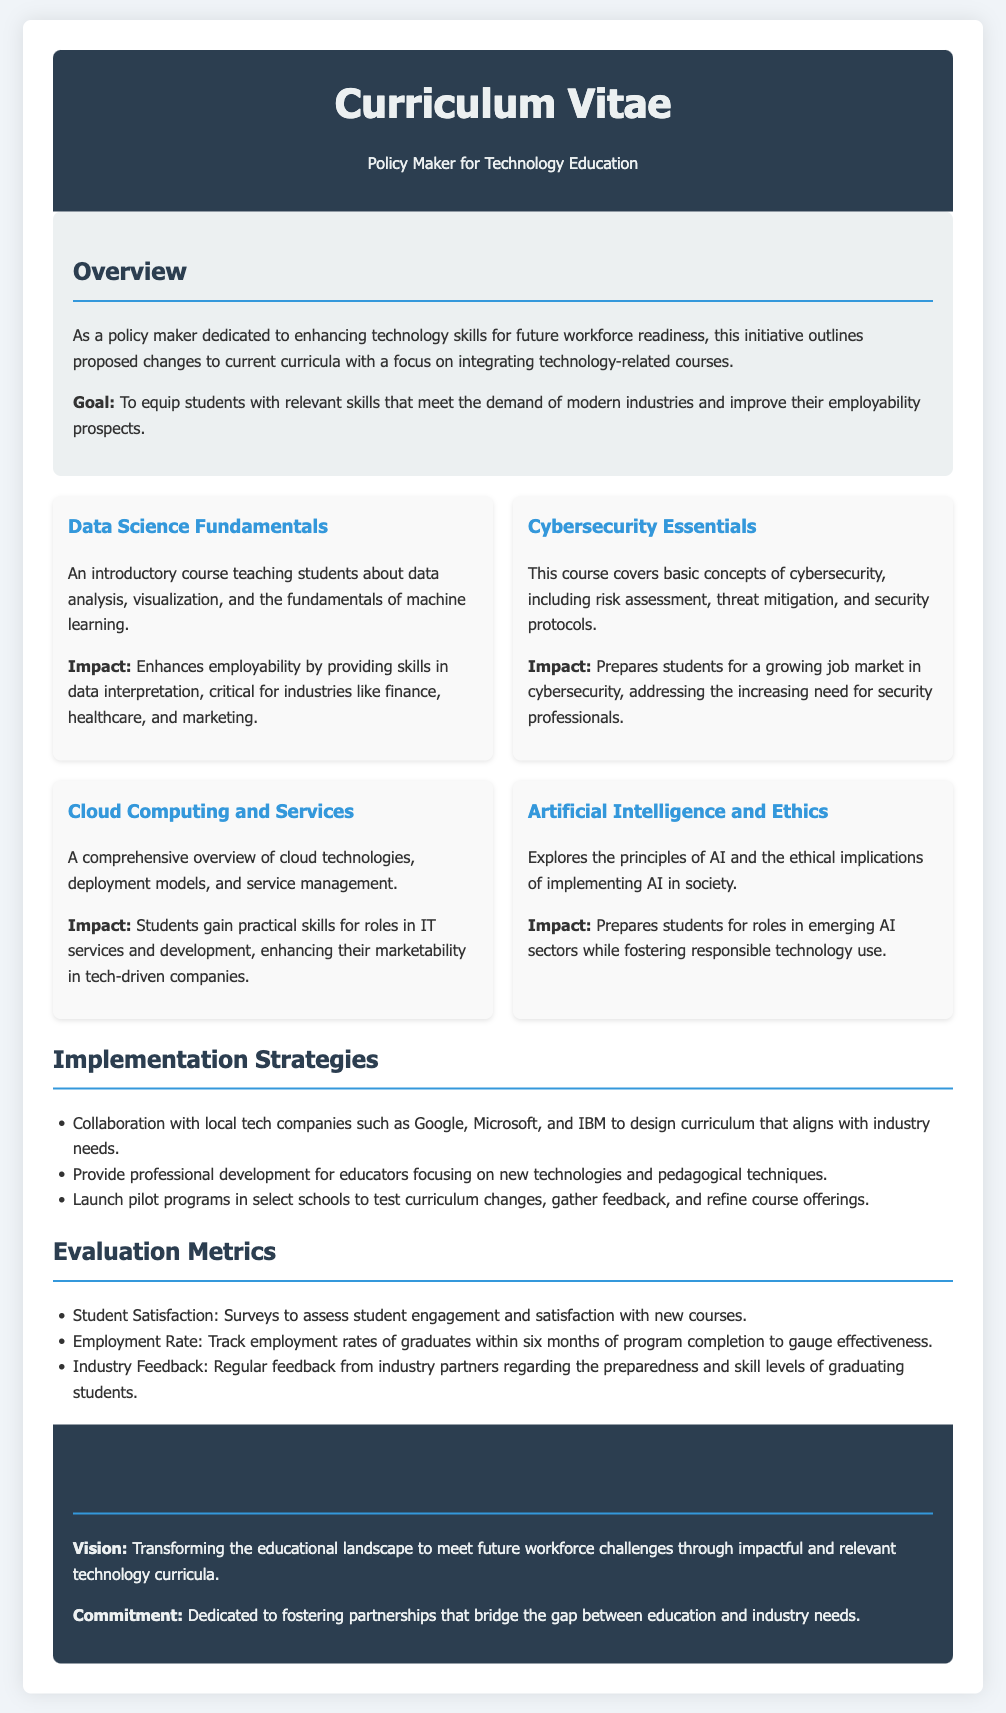what is the main goal of the curriculum changes? The goal is to equip students with relevant skills that meet the demand of modern industries and improve their employability prospects.
Answer: to equip students with relevant skills how many new technology-related courses are proposed? The document outlines four specific courses that are being proposed for the curriculum.
Answer: four which company is mentioned as a collaborator in curriculum design? Google is one of the local tech companies mentioned for collaboration on curriculum design.
Answer: Google what is a course that focuses on data analysis? The course that focuses on data analysis is titled "Data Science Fundamentals."
Answer: Data Science Fundamentals what type of impact does the "Cloud Computing and Services" course have? The impact of this course is that students gain practical skills for roles in IT services and development.
Answer: practical skills for roles in IT services what is the method for evaluating student satisfaction? Student satisfaction is evaluated through surveys to assess engagement and satisfaction with new courses.
Answer: surveys name one evaluation metric mentioned in the document. One evaluation metric mentioned is the track of employment rates of graduates.
Answer: employment rate what type of course is "Artificial Intelligence and Ethics"? The course "Artificial Intelligence and Ethics" explores the principles of AI and the ethical implications of implementing AI in society.
Answer: principles of AI and ethical implications what is a commitment stated in the conclusion section? The commitment stated is to fostering partnerships that bridge the gap between education and industry needs.
Answer: fostering partnerships 